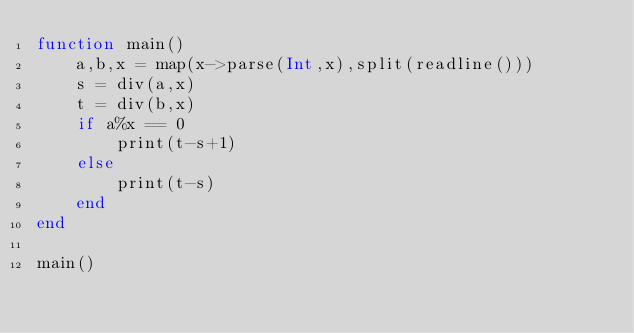Convert code to text. <code><loc_0><loc_0><loc_500><loc_500><_Julia_>function main()
	a,b,x = map(x->parse(Int,x),split(readline()))
	s = div(a,x)
	t = div(b,x)
	if a%x == 0
		print(t-s+1)
	else
		print(t-s)
	end
end

main()</code> 